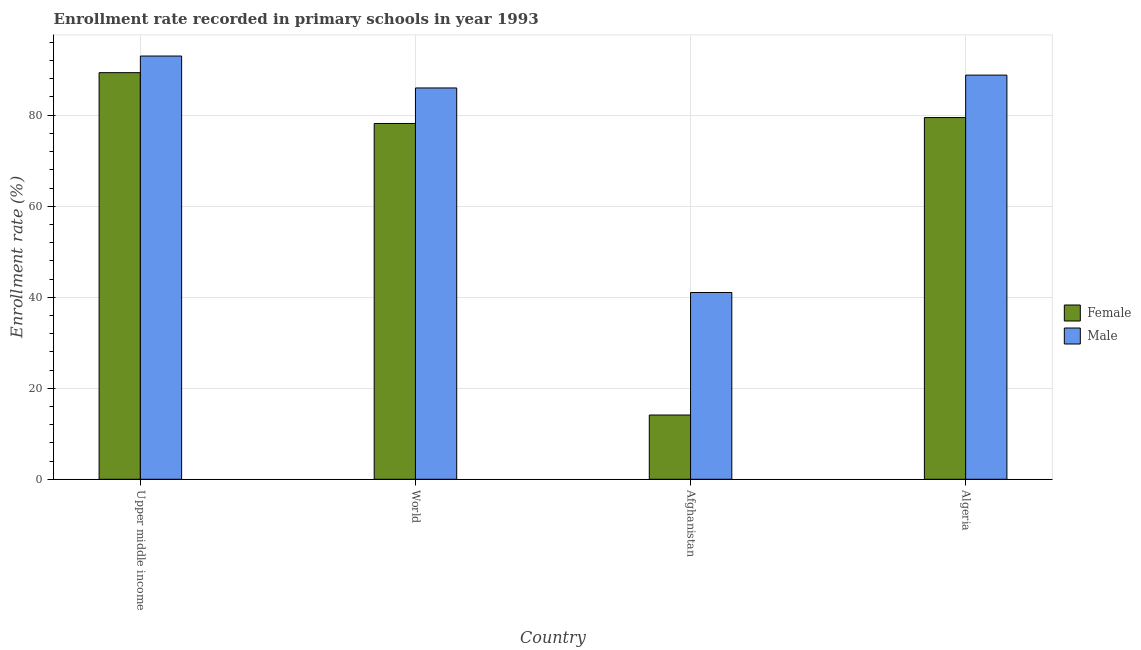How many different coloured bars are there?
Make the answer very short. 2. What is the label of the 3rd group of bars from the left?
Offer a very short reply. Afghanistan. What is the enrollment rate of female students in Afghanistan?
Offer a terse response. 14.12. Across all countries, what is the maximum enrollment rate of male students?
Give a very brief answer. 93. Across all countries, what is the minimum enrollment rate of female students?
Provide a succinct answer. 14.12. In which country was the enrollment rate of male students maximum?
Offer a very short reply. Upper middle income. In which country was the enrollment rate of male students minimum?
Offer a very short reply. Afghanistan. What is the total enrollment rate of female students in the graph?
Make the answer very short. 261.12. What is the difference between the enrollment rate of male students in Afghanistan and that in Upper middle income?
Your response must be concise. -51.96. What is the difference between the enrollment rate of male students in Algeria and the enrollment rate of female students in World?
Give a very brief answer. 10.63. What is the average enrollment rate of female students per country?
Make the answer very short. 65.28. What is the difference between the enrollment rate of female students and enrollment rate of male students in World?
Your response must be concise. -7.81. What is the ratio of the enrollment rate of male students in Afghanistan to that in World?
Your answer should be compact. 0.48. Is the difference between the enrollment rate of female students in Afghanistan and Algeria greater than the difference between the enrollment rate of male students in Afghanistan and Algeria?
Your answer should be compact. No. What is the difference between the highest and the second highest enrollment rate of female students?
Ensure brevity in your answer.  9.87. What is the difference between the highest and the lowest enrollment rate of female students?
Your response must be concise. 75.23. In how many countries, is the enrollment rate of female students greater than the average enrollment rate of female students taken over all countries?
Keep it short and to the point. 3. What does the 1st bar from the left in Algeria represents?
Offer a terse response. Female. How many bars are there?
Your response must be concise. 8. Are all the bars in the graph horizontal?
Make the answer very short. No. Are the values on the major ticks of Y-axis written in scientific E-notation?
Give a very brief answer. No. Does the graph contain any zero values?
Make the answer very short. No. Does the graph contain grids?
Keep it short and to the point. Yes. How are the legend labels stacked?
Keep it short and to the point. Vertical. What is the title of the graph?
Ensure brevity in your answer.  Enrollment rate recorded in primary schools in year 1993. Does "Males" appear as one of the legend labels in the graph?
Keep it short and to the point. No. What is the label or title of the X-axis?
Your answer should be very brief. Country. What is the label or title of the Y-axis?
Your answer should be very brief. Enrollment rate (%). What is the Enrollment rate (%) of Female in Upper middle income?
Your response must be concise. 89.34. What is the Enrollment rate (%) in Male in Upper middle income?
Your response must be concise. 93. What is the Enrollment rate (%) in Female in World?
Provide a short and direct response. 78.18. What is the Enrollment rate (%) in Male in World?
Your answer should be compact. 85.98. What is the Enrollment rate (%) of Female in Afghanistan?
Your answer should be compact. 14.12. What is the Enrollment rate (%) of Male in Afghanistan?
Give a very brief answer. 41.04. What is the Enrollment rate (%) of Female in Algeria?
Your response must be concise. 79.48. What is the Enrollment rate (%) in Male in Algeria?
Your response must be concise. 88.81. Across all countries, what is the maximum Enrollment rate (%) in Female?
Provide a short and direct response. 89.34. Across all countries, what is the maximum Enrollment rate (%) of Male?
Provide a short and direct response. 93. Across all countries, what is the minimum Enrollment rate (%) of Female?
Keep it short and to the point. 14.12. Across all countries, what is the minimum Enrollment rate (%) in Male?
Provide a short and direct response. 41.04. What is the total Enrollment rate (%) of Female in the graph?
Offer a terse response. 261.12. What is the total Enrollment rate (%) in Male in the graph?
Ensure brevity in your answer.  308.83. What is the difference between the Enrollment rate (%) of Female in Upper middle income and that in World?
Your response must be concise. 11.17. What is the difference between the Enrollment rate (%) of Male in Upper middle income and that in World?
Make the answer very short. 7.01. What is the difference between the Enrollment rate (%) in Female in Upper middle income and that in Afghanistan?
Offer a very short reply. 75.23. What is the difference between the Enrollment rate (%) in Male in Upper middle income and that in Afghanistan?
Your answer should be compact. 51.96. What is the difference between the Enrollment rate (%) in Female in Upper middle income and that in Algeria?
Ensure brevity in your answer.  9.87. What is the difference between the Enrollment rate (%) in Male in Upper middle income and that in Algeria?
Keep it short and to the point. 4.19. What is the difference between the Enrollment rate (%) of Female in World and that in Afghanistan?
Provide a short and direct response. 64.06. What is the difference between the Enrollment rate (%) of Male in World and that in Afghanistan?
Provide a short and direct response. 44.95. What is the difference between the Enrollment rate (%) of Female in World and that in Algeria?
Your answer should be very brief. -1.3. What is the difference between the Enrollment rate (%) of Male in World and that in Algeria?
Provide a short and direct response. -2.82. What is the difference between the Enrollment rate (%) of Female in Afghanistan and that in Algeria?
Provide a short and direct response. -65.36. What is the difference between the Enrollment rate (%) of Male in Afghanistan and that in Algeria?
Ensure brevity in your answer.  -47.77. What is the difference between the Enrollment rate (%) in Female in Upper middle income and the Enrollment rate (%) in Male in World?
Your answer should be very brief. 3.36. What is the difference between the Enrollment rate (%) of Female in Upper middle income and the Enrollment rate (%) of Male in Afghanistan?
Keep it short and to the point. 48.31. What is the difference between the Enrollment rate (%) of Female in Upper middle income and the Enrollment rate (%) of Male in Algeria?
Make the answer very short. 0.54. What is the difference between the Enrollment rate (%) in Female in World and the Enrollment rate (%) in Male in Afghanistan?
Provide a succinct answer. 37.14. What is the difference between the Enrollment rate (%) of Female in World and the Enrollment rate (%) of Male in Algeria?
Ensure brevity in your answer.  -10.63. What is the difference between the Enrollment rate (%) in Female in Afghanistan and the Enrollment rate (%) in Male in Algeria?
Offer a very short reply. -74.69. What is the average Enrollment rate (%) in Female per country?
Your response must be concise. 65.28. What is the average Enrollment rate (%) in Male per country?
Ensure brevity in your answer.  77.21. What is the difference between the Enrollment rate (%) in Female and Enrollment rate (%) in Male in Upper middle income?
Your answer should be compact. -3.65. What is the difference between the Enrollment rate (%) of Female and Enrollment rate (%) of Male in World?
Your response must be concise. -7.81. What is the difference between the Enrollment rate (%) of Female and Enrollment rate (%) of Male in Afghanistan?
Give a very brief answer. -26.92. What is the difference between the Enrollment rate (%) of Female and Enrollment rate (%) of Male in Algeria?
Provide a succinct answer. -9.33. What is the ratio of the Enrollment rate (%) in Female in Upper middle income to that in World?
Make the answer very short. 1.14. What is the ratio of the Enrollment rate (%) in Male in Upper middle income to that in World?
Offer a terse response. 1.08. What is the ratio of the Enrollment rate (%) of Female in Upper middle income to that in Afghanistan?
Provide a short and direct response. 6.33. What is the ratio of the Enrollment rate (%) in Male in Upper middle income to that in Afghanistan?
Offer a very short reply. 2.27. What is the ratio of the Enrollment rate (%) of Female in Upper middle income to that in Algeria?
Offer a terse response. 1.12. What is the ratio of the Enrollment rate (%) of Male in Upper middle income to that in Algeria?
Provide a short and direct response. 1.05. What is the ratio of the Enrollment rate (%) of Female in World to that in Afghanistan?
Make the answer very short. 5.54. What is the ratio of the Enrollment rate (%) of Male in World to that in Afghanistan?
Provide a short and direct response. 2.1. What is the ratio of the Enrollment rate (%) in Female in World to that in Algeria?
Your answer should be compact. 0.98. What is the ratio of the Enrollment rate (%) of Male in World to that in Algeria?
Provide a succinct answer. 0.97. What is the ratio of the Enrollment rate (%) of Female in Afghanistan to that in Algeria?
Give a very brief answer. 0.18. What is the ratio of the Enrollment rate (%) in Male in Afghanistan to that in Algeria?
Offer a terse response. 0.46. What is the difference between the highest and the second highest Enrollment rate (%) of Female?
Offer a terse response. 9.87. What is the difference between the highest and the second highest Enrollment rate (%) in Male?
Offer a very short reply. 4.19. What is the difference between the highest and the lowest Enrollment rate (%) of Female?
Provide a short and direct response. 75.23. What is the difference between the highest and the lowest Enrollment rate (%) of Male?
Offer a very short reply. 51.96. 